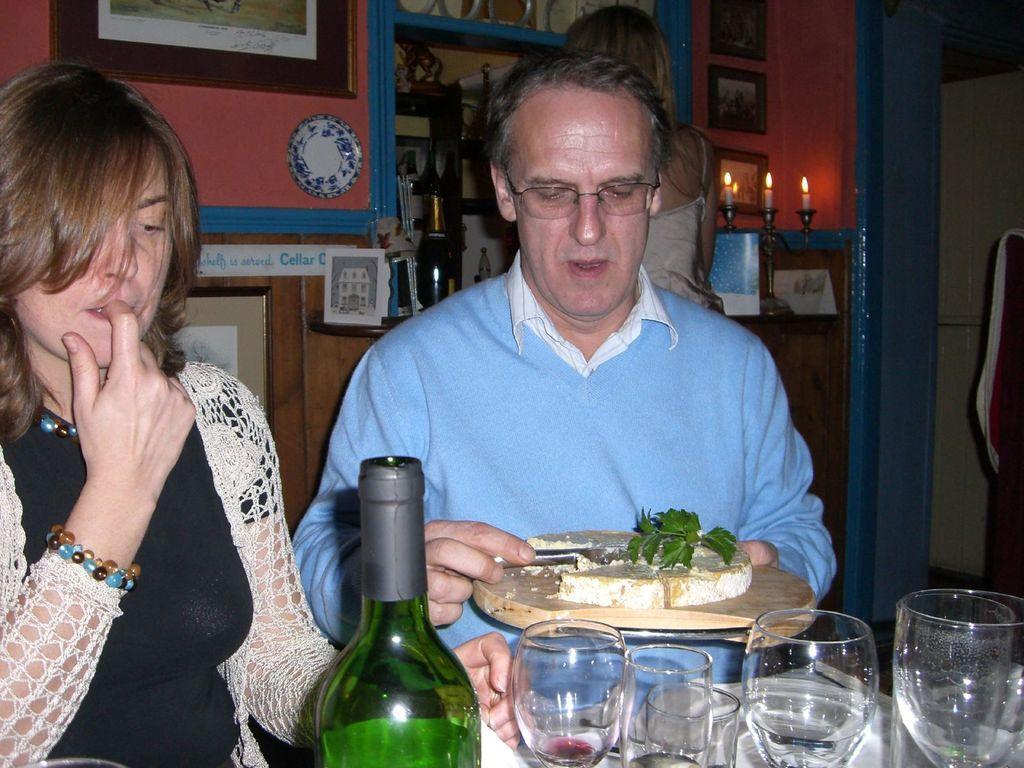Please provide a concise description of this image. Two persons are sitting. A man wearing specs is holding a tray. On the train there are some food items. In front of them there is a bottle And many glasses. In the background there is a candle with candle stand, photo frames on the wall, plate and many other items kept on the wall. 